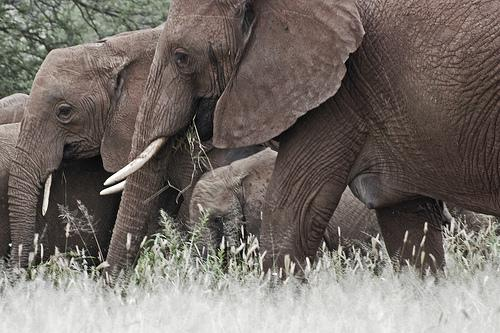Question: what is it?
Choices:
A. Tiger.
B. Lion.
C. Elephant.
D. Giraffe.
Answer with the letter. Answer: C Question: what are they doing?
Choices:
A. Drinking.
B. Grazing.
C. Sleeping.
D. Fighting.
Answer with the letter. Answer: B Question: what color are they?
Choices:
A. Brown.
B. Green.
C. Red.
D. White.
Answer with the letter. Answer: A Question: where are they?
Choices:
A. Nature.
B. An ocean.
C. A house.
D. A town.
Answer with the letter. Answer: A Question: where are their trunks?
Choices:
A. Dirt.
B. Water.
C. Sand.
D. Grass.
Answer with the letter. Answer: D Question: how many elephants are there?
Choices:
A. Three.
B. Six.
C. Four.
D. Five.
Answer with the letter. Answer: C Question: how many baby elephants are there?
Choices:
A. Two.
B. Three.
C. One.
D. Four.
Answer with the letter. Answer: C 